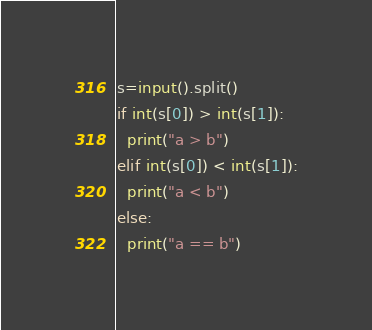Convert code to text. <code><loc_0><loc_0><loc_500><loc_500><_Python_>s=input().split()
if int(s[0]) > int(s[1]):
  print("a > b")
elif int(s[0]) < int(s[1]):
  print("a < b")
else:
  print("a == b")

</code> 